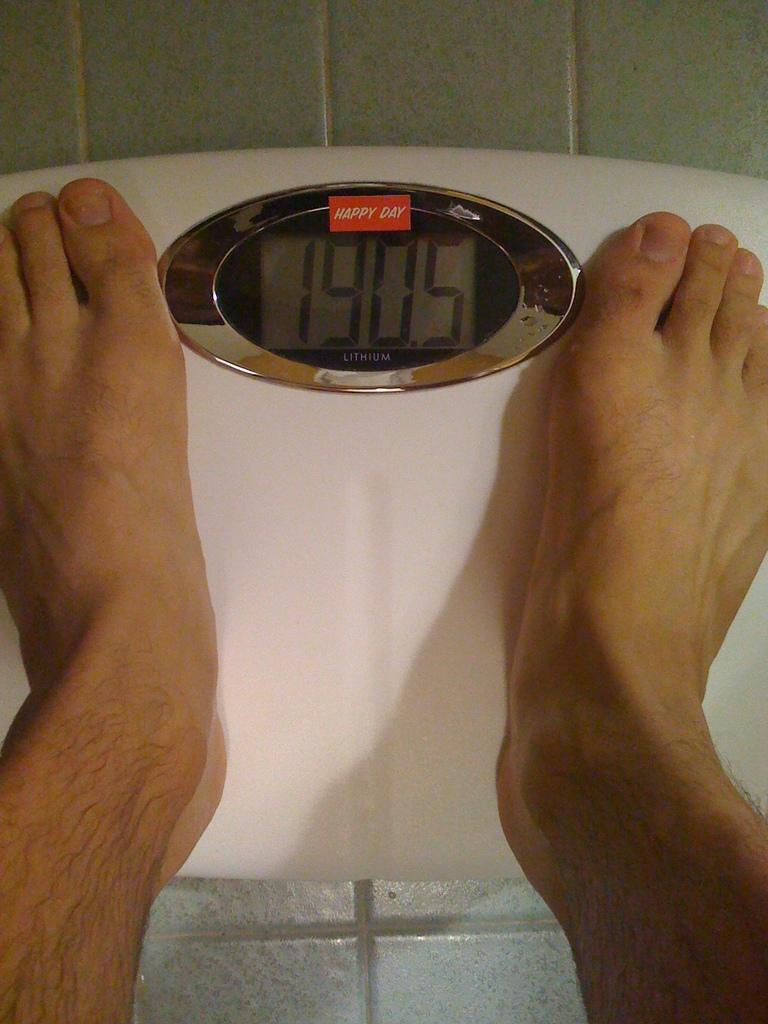<image>
Render a clear and concise summary of the photo. A man's feet on a white scale displaying 190.5 beneath a read Happy Day logo. 